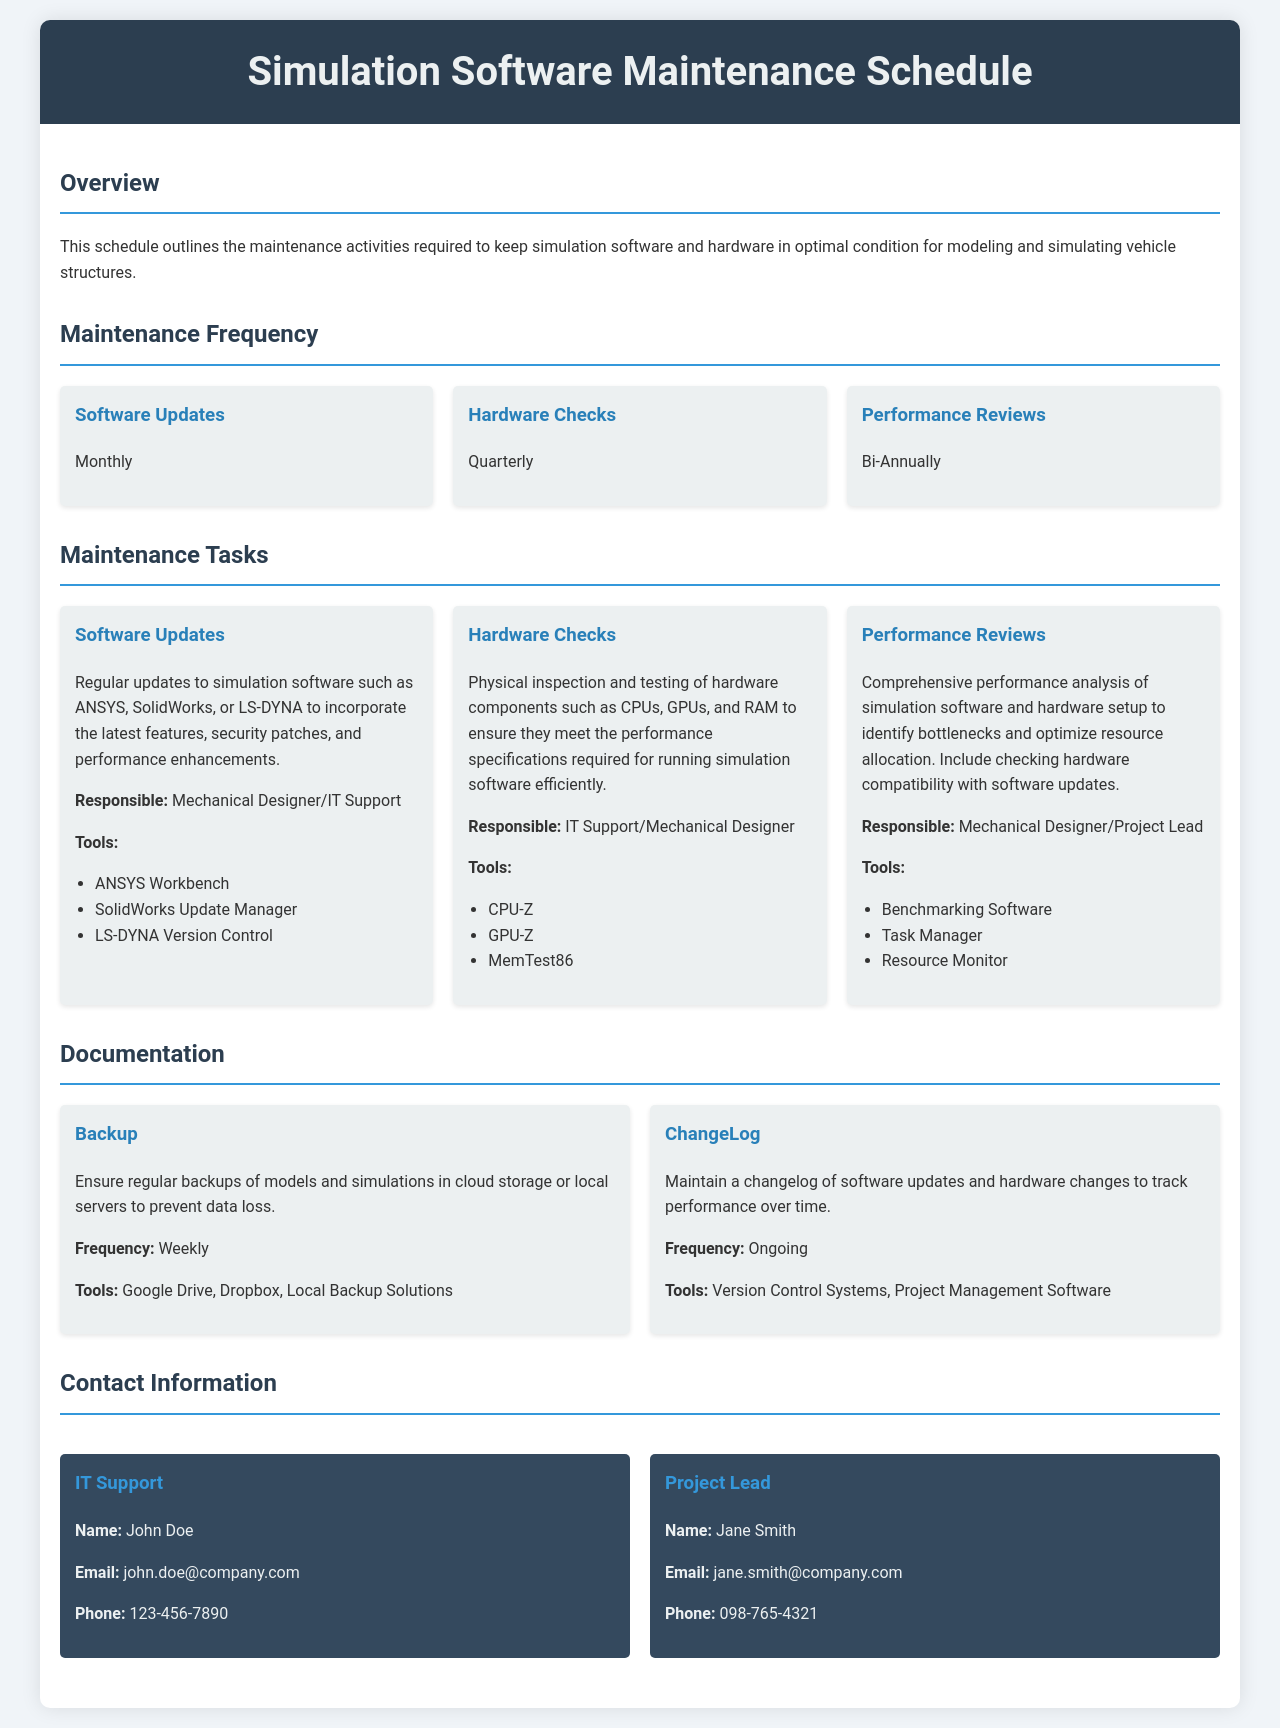What is the title of the document? The title is presented in the header section of the document.
Answer: Simulation Software Maintenance Schedule What frequency are software updates scheduled? The maintenance frequency section states the schedule for software updates.
Answer: Monthly Who is responsible for hardware checks? The maintenance tasks section specifies the responsible parties for hardware checks.
Answer: IT Support/Mechanical Designer What is the frequency of performance reviews? The maintenance frequency section outlines how often performance reviews are conducted.
Answer: Bi-Annually Which tool is used for software updates? Tools associated with software updates are listed under the maintenance tasks section.
Answer: ANSYS Workbench How often should backups be performed? The documentation section states the frequency at which backups must occur.
Answer: Weekly Who can be contacted for IT support? The contact information section provides the name of the IT support individual.
Answer: John Doe What is one tool used for hardware checks? Tools related to hardware checks are mentioned in the maintenance tasks section.
Answer: CPU-Z How often are hardware checks performed? The maintenance frequency section indicates the timing of hardware checks.
Answer: Quarterly 